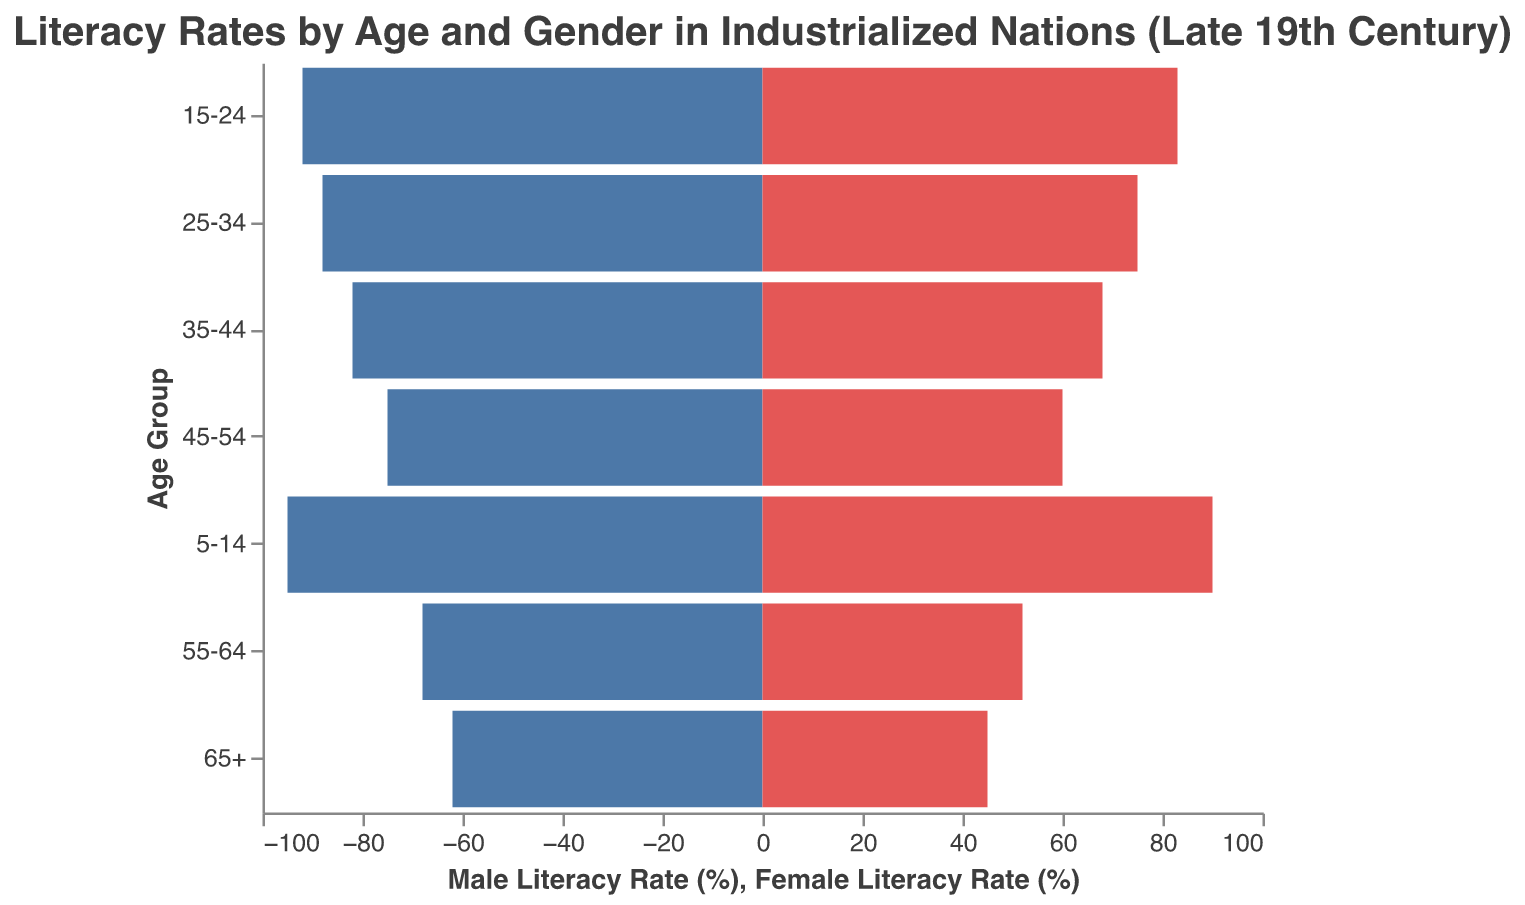What is the literacy rate for males aged 35-44? To find the literacy rate for males aged 35-44, look for the "35-44" age group and note the value under "Male Literacy Rate."
Answer: 82% What is the difference in literacy rates between males and females aged 55-64? Identify the literacy rates for the "55-64" age group for both genders and subtract the female rate from the male rate (68 - 52).
Answer: 16% Which age group has the highest literacy rates for both males and females? Compare the literacy rates across all age groups for both genders and identify which group has the highest values.
Answer: 5-14 What is the range of literacy rates for females across all age groups? To calculate the range, find the difference between the highest and the lowest female literacy rates in the dataset (90 - 45).
Answer: 45 How does the literacy rate of females aged 15-24 compare to males in the same age group? Refer to the "15-24" age group and compare the female literacy rate (83) to the male literacy rate (92).
Answer: 9% lower What trend can be observed in the literacy rates as age decreases in the chart? By examining the chart from older to younger age groups, observe the increase in literacy rates for both genders.
Answer: Increasing trend Calculate the average literacy rate for males across all age groups. Sum the male literacy rates and divide by the number of age groups ((62 + 68 + 75 + 82 + 88 + 92 + 95)/7).
Answer: 80.3% Which age group shows the smallest gender gap in literacy rates? Determine the difference between male and female literacy rates for each age group and find the smallest value.
Answer: 5-14 How much higher is the male literacy rate for the 25-34 age group compared to the female rate in the same group? Identify the literacy rates for the "25-34" age group and subtract the female rate from the male rate (88 - 75).
Answer: 13% What might explain the overall differences in literacy rates between males and females during this period? Consider historical factors, such as limited access to education for women during the late 19th century, which might contribute to the observed differences.
Answer: Historical access to education 